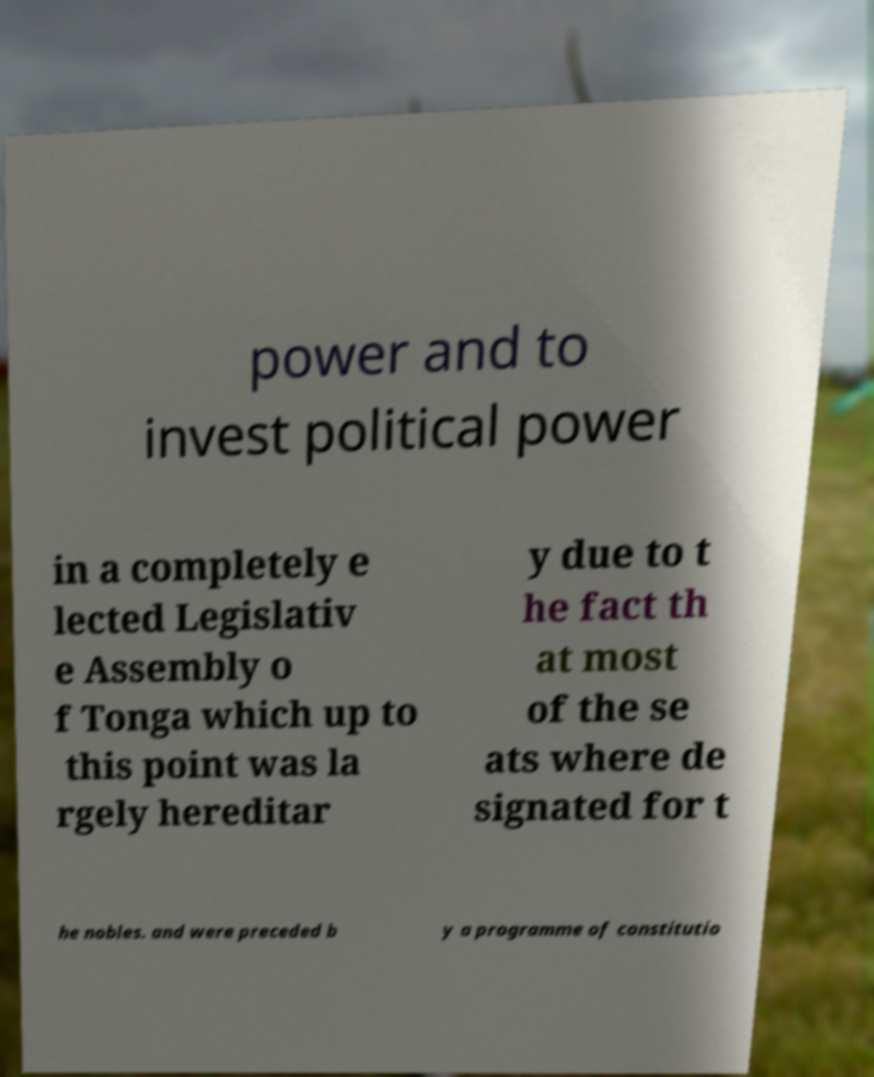What messages or text are displayed in this image? I need them in a readable, typed format. power and to invest political power in a completely e lected Legislativ e Assembly o f Tonga which up to this point was la rgely hereditar y due to t he fact th at most of the se ats where de signated for t he nobles. and were preceded b y a programme of constitutio 